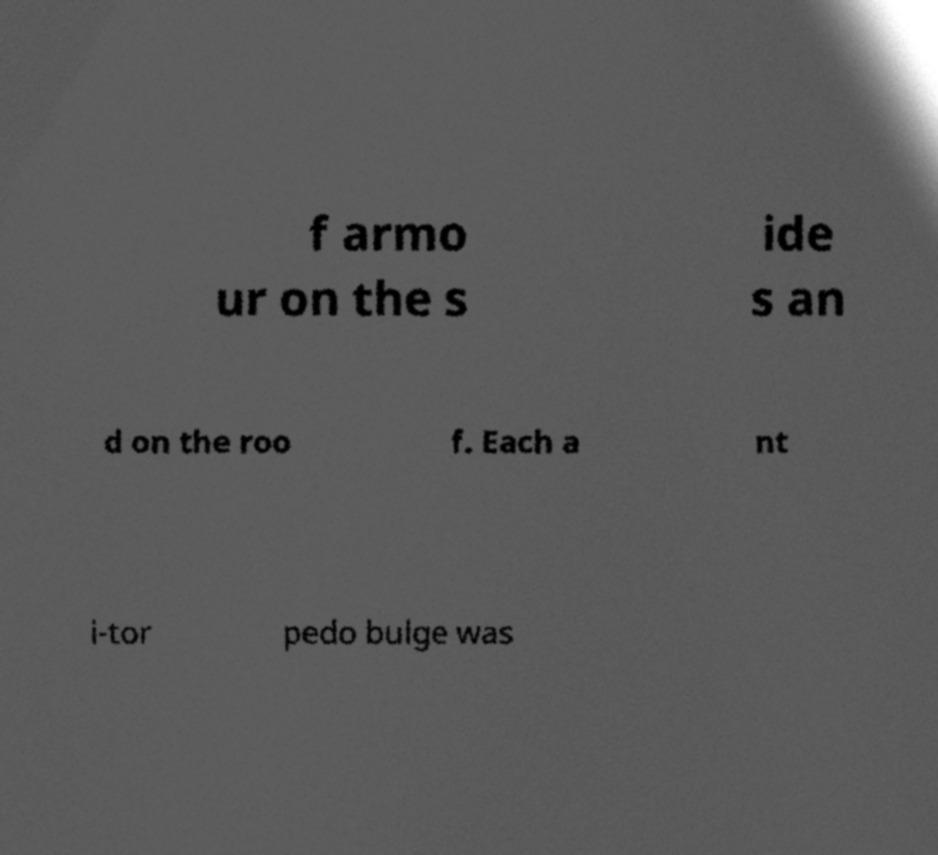I need the written content from this picture converted into text. Can you do that? f armo ur on the s ide s an d on the roo f. Each a nt i-tor pedo bulge was 